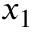Convert formula to latex. <formula><loc_0><loc_0><loc_500><loc_500>x _ { 1 }</formula> 